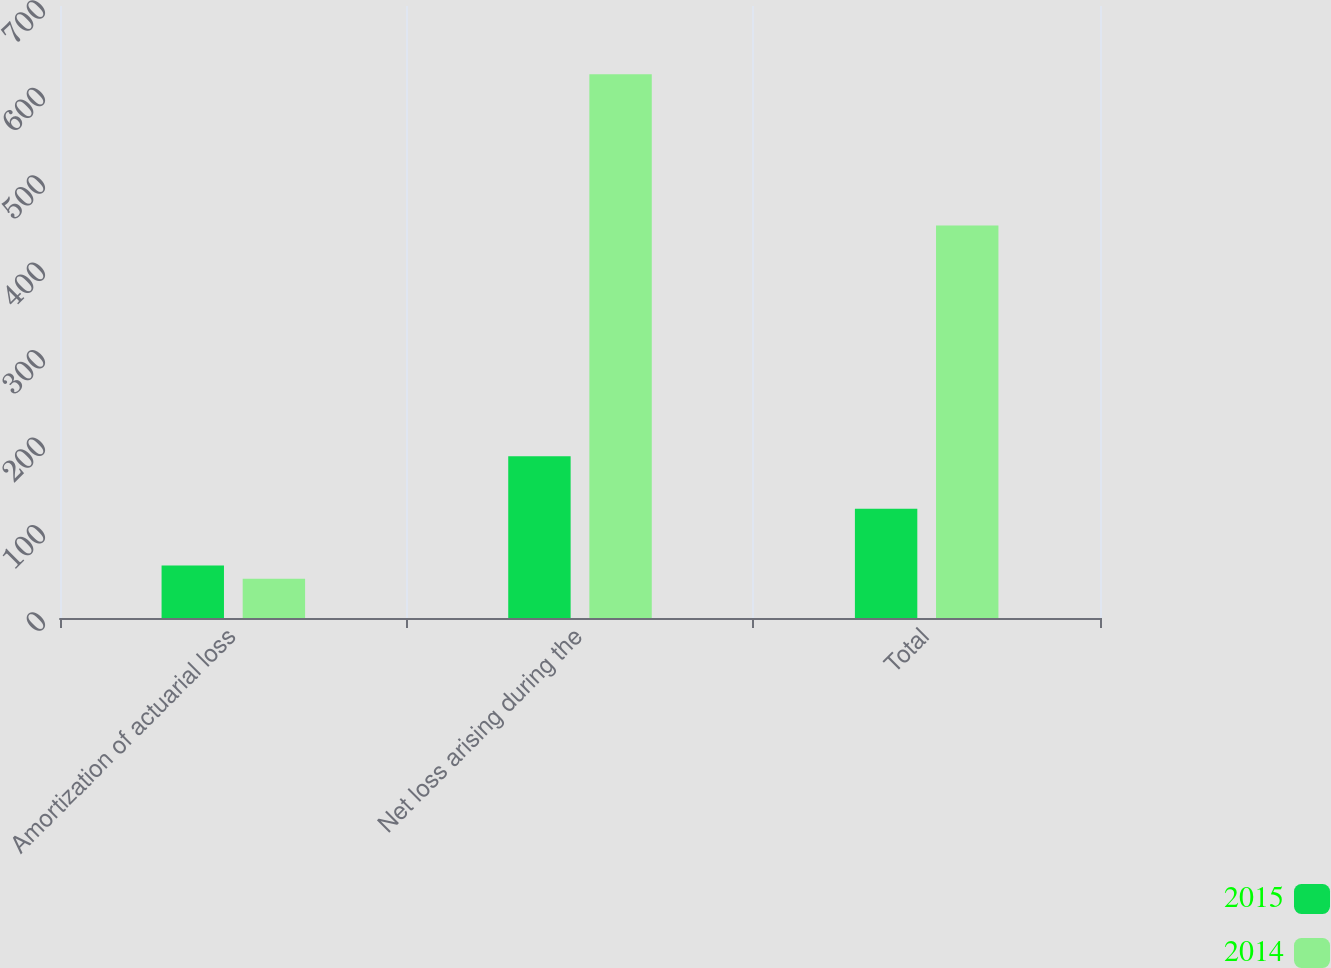Convert chart. <chart><loc_0><loc_0><loc_500><loc_500><stacked_bar_chart><ecel><fcel>Amortization of actuarial loss<fcel>Net loss arising during the<fcel>Total<nl><fcel>2015<fcel>60<fcel>185<fcel>125<nl><fcel>2014<fcel>45<fcel>622<fcel>449<nl></chart> 